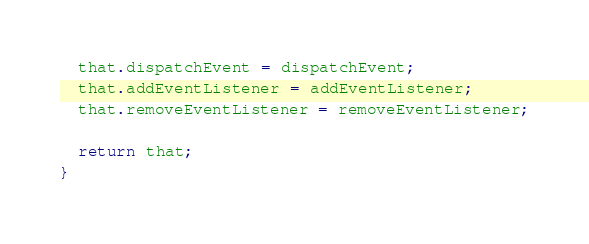Convert code to text. <code><loc_0><loc_0><loc_500><loc_500><_JavaScript_>  that.dispatchEvent = dispatchEvent;
  that.addEventListener = addEventListener;
  that.removeEventListener = removeEventListener;

  return that;
}

</code> 